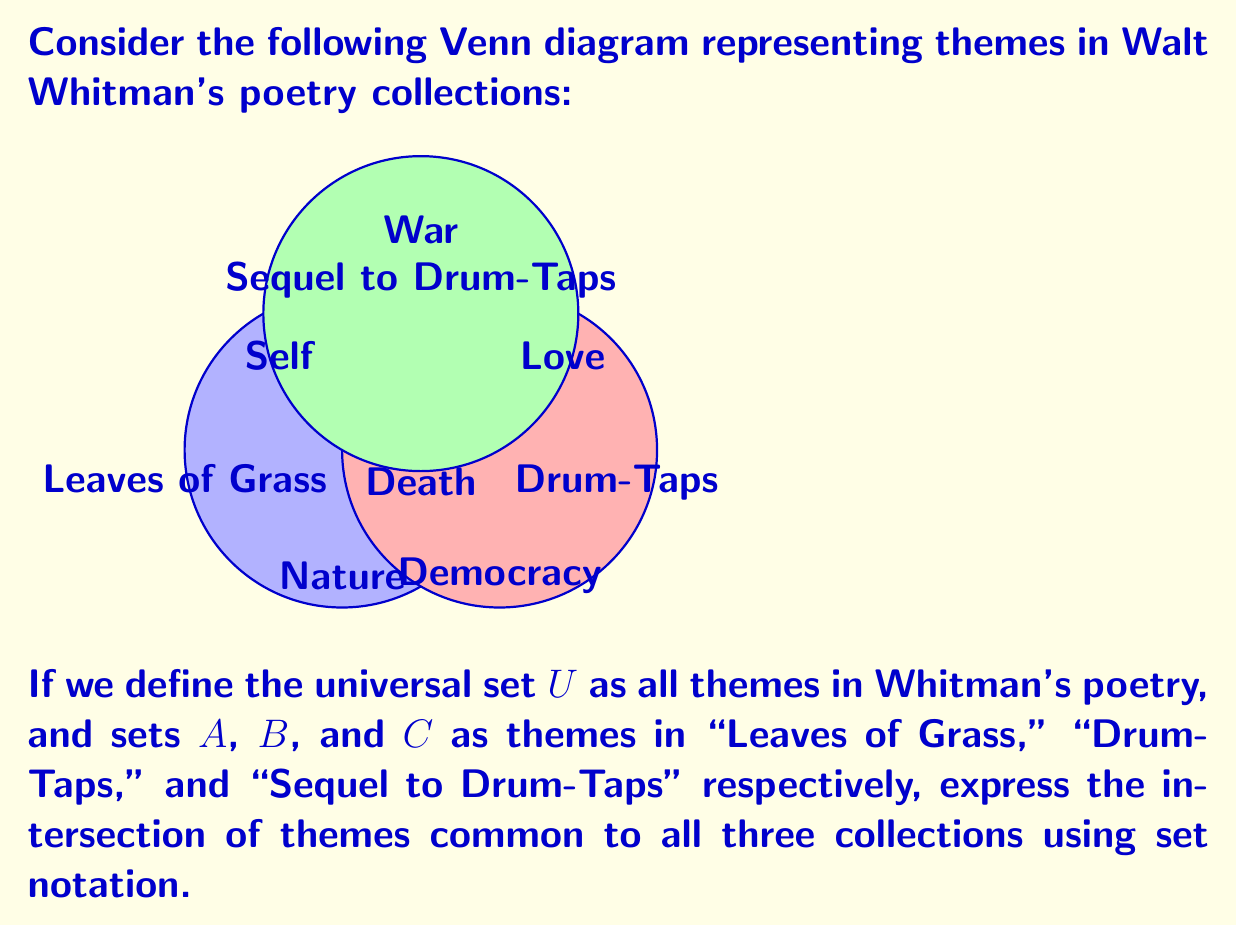Could you help me with this problem? To find the intersection of themes common to all three collections, we need to identify the region where all three circles overlap in the Venn diagram. This region represents the themes that are present in all three collections.

Let's approach this step-by-step:

1) The set notation for the intersection of sets $A$, $B$, and $C$ is $A \cap B \cap C$.

2) From the Venn diagram, we can see that the central region where all three circles overlap contains the theme "Death".

3) This means that "Death" is a theme that appears in all three collections: "Leaves of Grass," "Drum-Taps," and "Sequel to Drum-Taps".

4) In set theory notation, we can express this as:

   $A \cap B \cap C = \{\text{Death}\}$

This notation indicates that the set containing only the element "Death" is the result of the intersection of all three sets.
Answer: $A \cap B \cap C = \{\text{Death}\}$ 